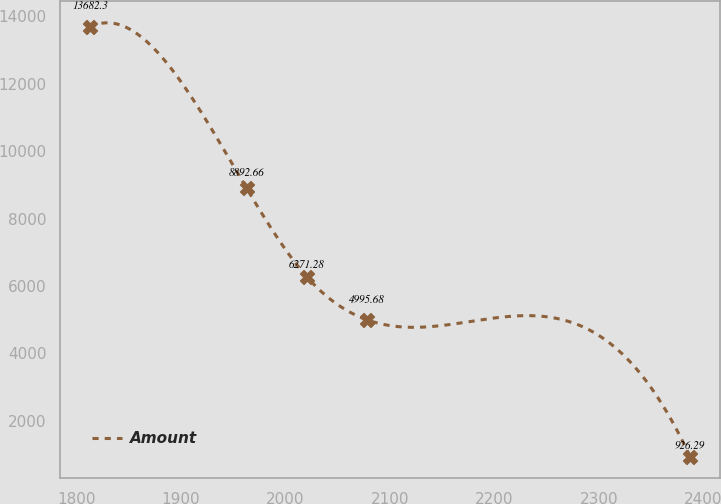<chart> <loc_0><loc_0><loc_500><loc_500><line_chart><ecel><fcel>Amount<nl><fcel>1813.01<fcel>13682.3<nl><fcel>1963.02<fcel>8892.66<nl><fcel>2020.43<fcel>6271.28<nl><fcel>2077.84<fcel>4995.68<nl><fcel>2387.08<fcel>926.29<nl></chart> 